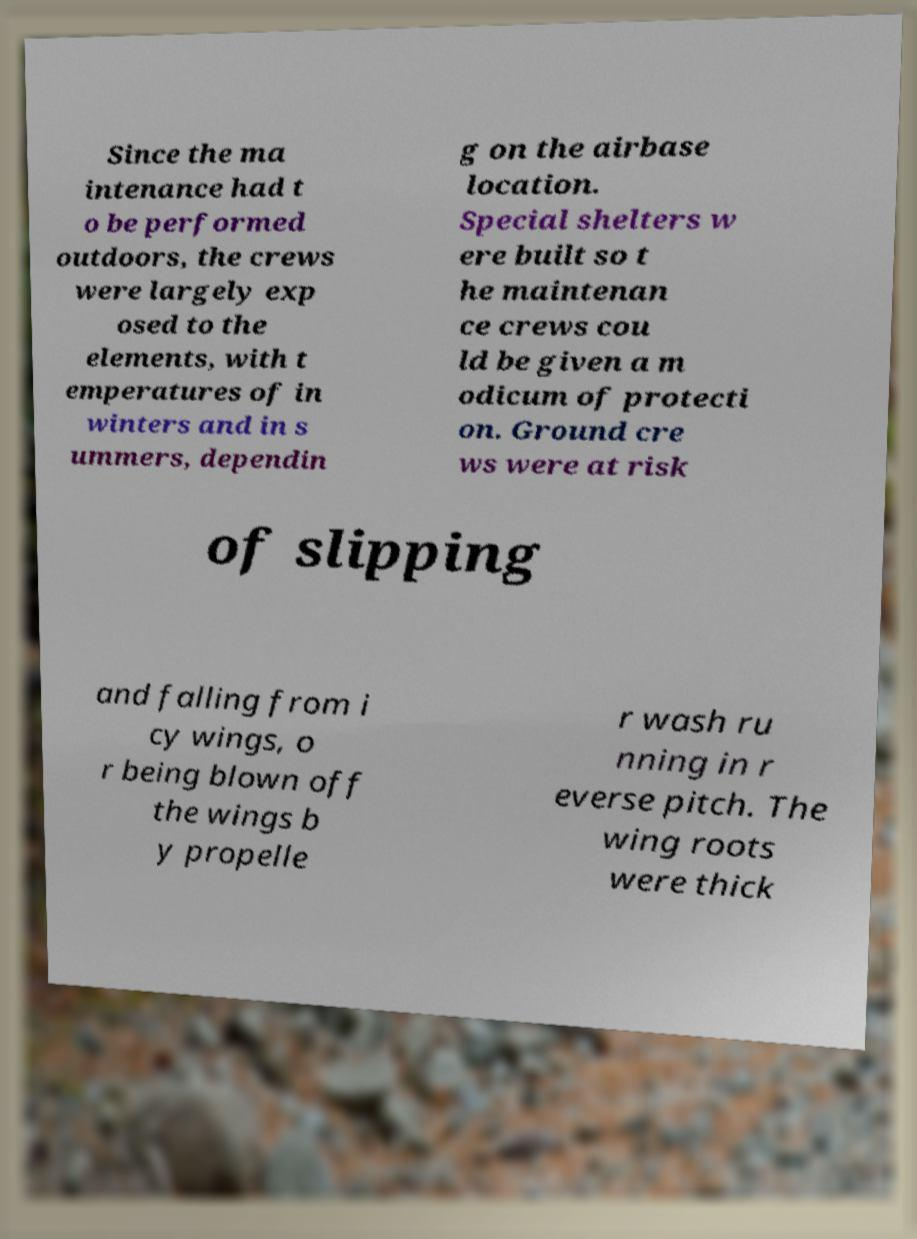Could you extract and type out the text from this image? Since the ma intenance had t o be performed outdoors, the crews were largely exp osed to the elements, with t emperatures of in winters and in s ummers, dependin g on the airbase location. Special shelters w ere built so t he maintenan ce crews cou ld be given a m odicum of protecti on. Ground cre ws were at risk of slipping and falling from i cy wings, o r being blown off the wings b y propelle r wash ru nning in r everse pitch. The wing roots were thick 